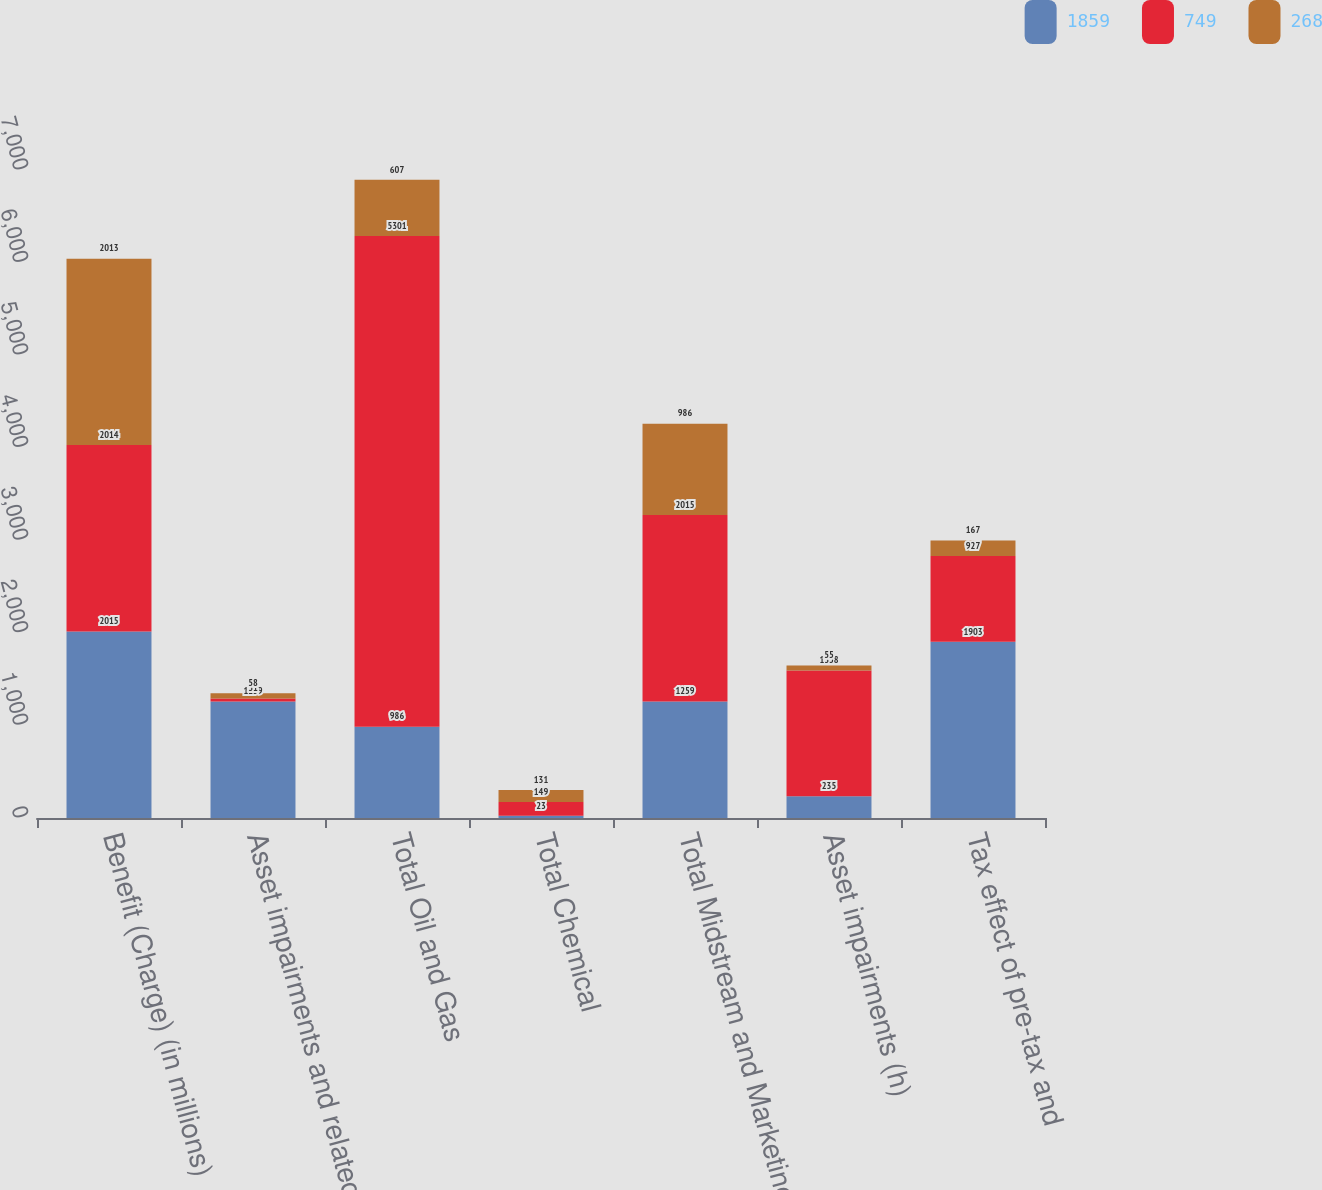Convert chart to OTSL. <chart><loc_0><loc_0><loc_500><loc_500><stacked_bar_chart><ecel><fcel>Benefit (Charge) (in millions)<fcel>Asset impairments and related<fcel>Total Oil and Gas<fcel>Total Chemical<fcel>Total Midstream and Marketing<fcel>Asset impairments (h)<fcel>Tax effect of pre-tax and<nl><fcel>1859<fcel>2015<fcel>1259<fcel>986<fcel>23<fcel>1259<fcel>235<fcel>1903<nl><fcel>749<fcel>2014<fcel>31<fcel>5301<fcel>149<fcel>2015<fcel>1358<fcel>927<nl><fcel>268<fcel>2013<fcel>58<fcel>607<fcel>131<fcel>986<fcel>55<fcel>167<nl></chart> 